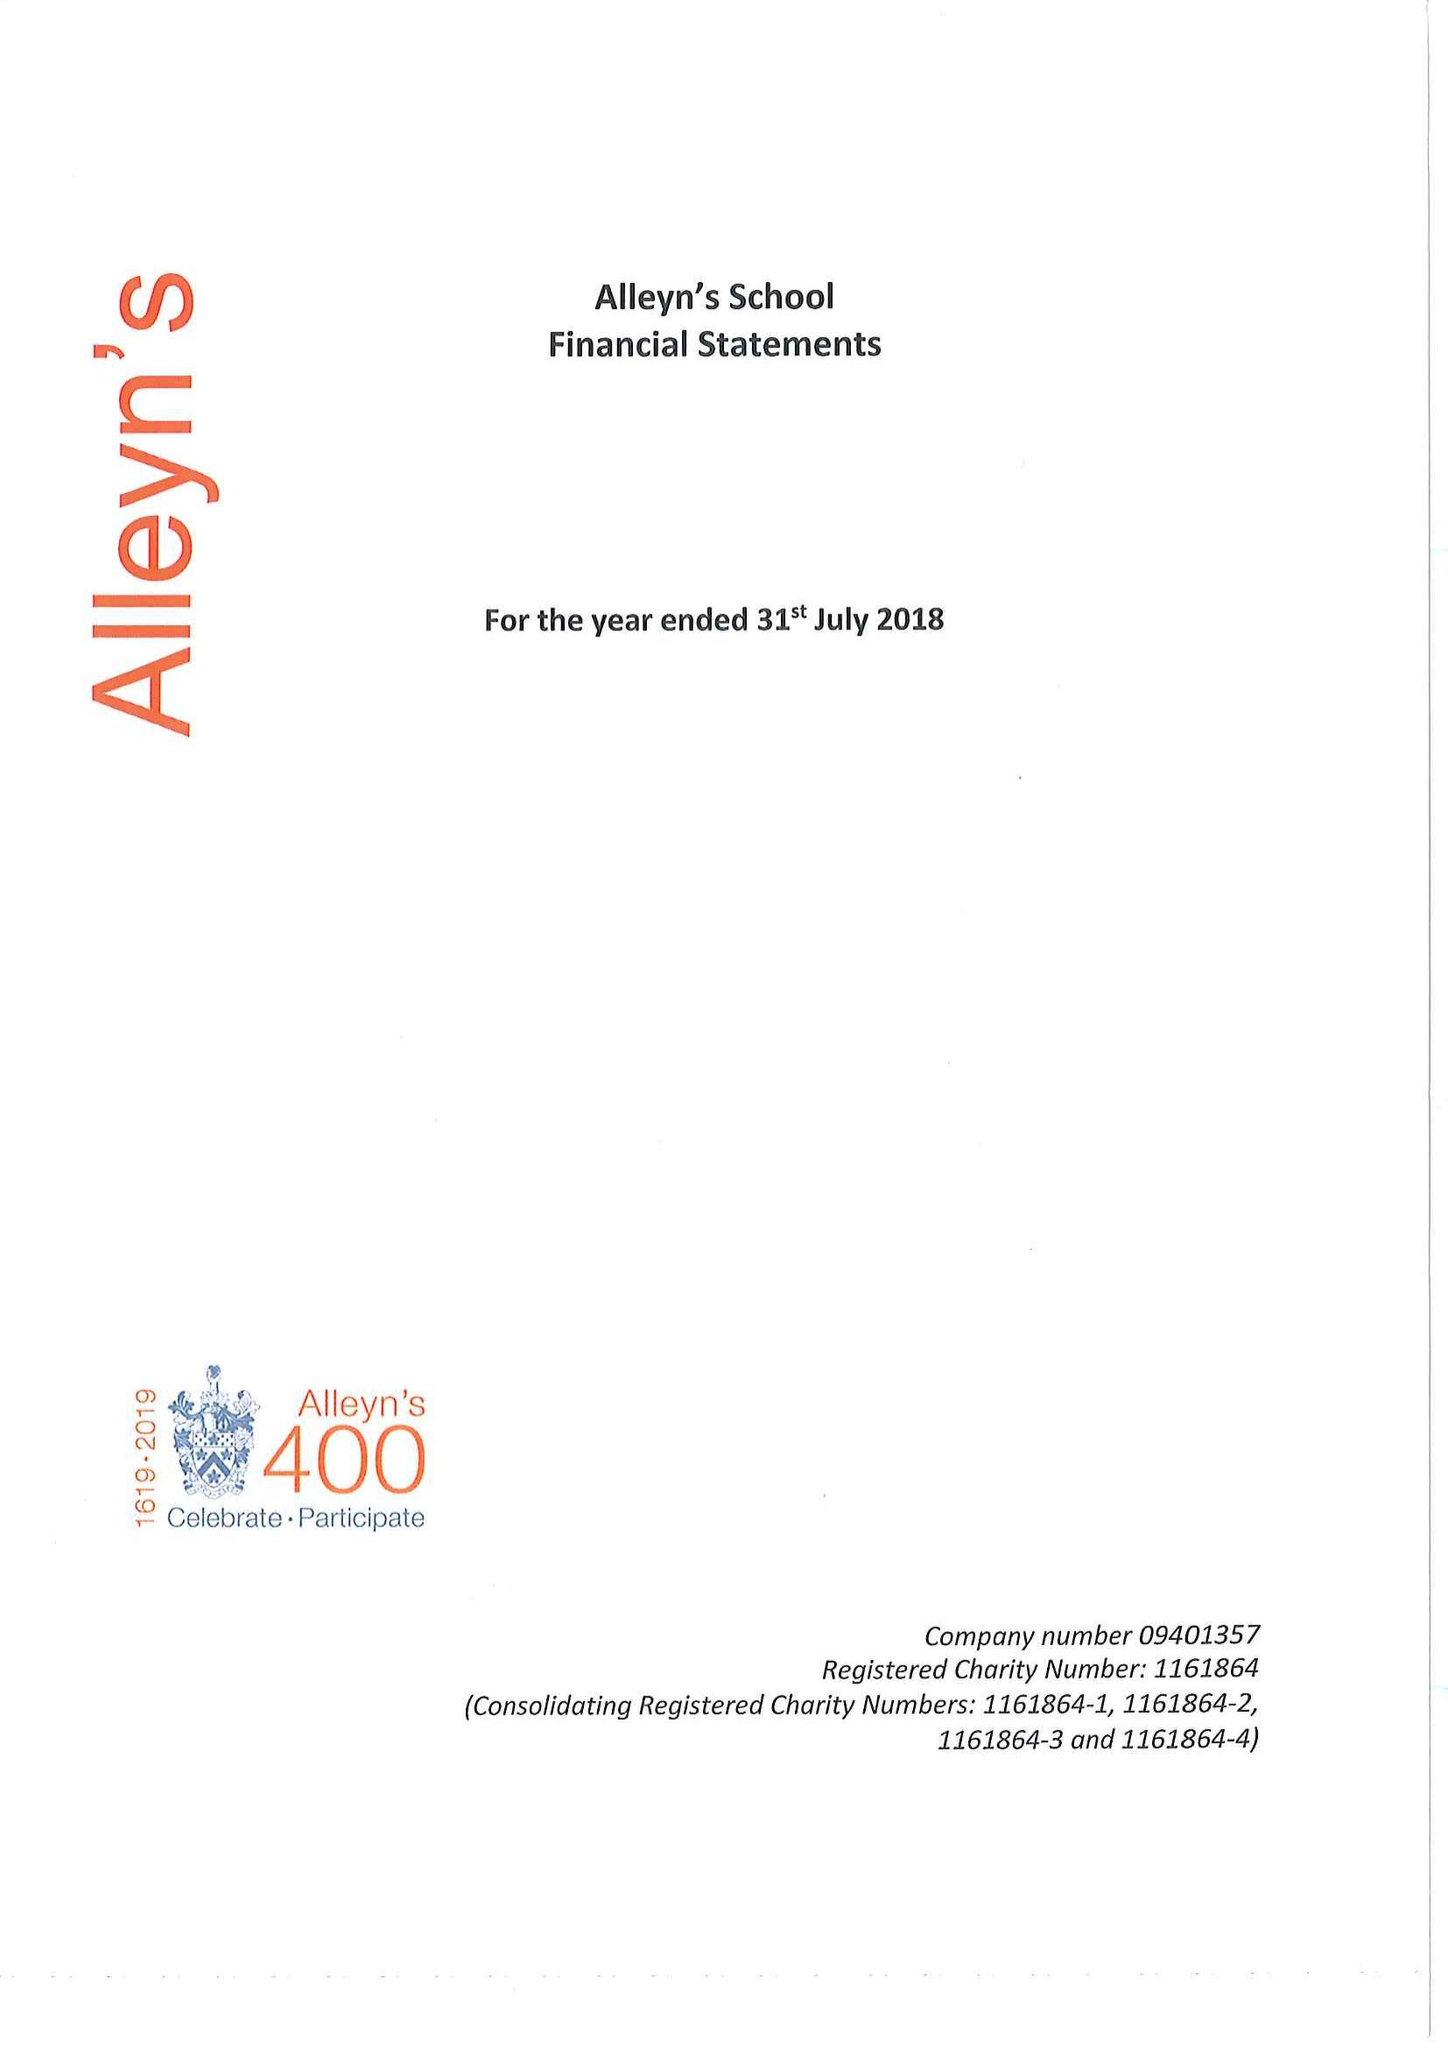What is the value for the income_annually_in_british_pounds?
Answer the question using a single word or phrase. 24326000.00 